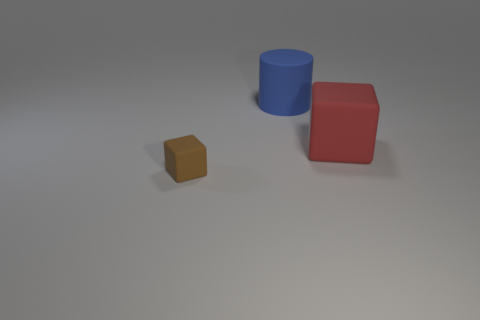Can you describe the lighting and shadows in the scene? The lighting in the scene appears to be coming from the upper left side, casting soft shadows towards the lower right. The shadows are not very sharp, suggesting that the light source is not extremely close. The objects each have distinct but soft-edged shadows that match their shapes. 